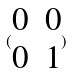Convert formula to latex. <formula><loc_0><loc_0><loc_500><loc_500>( \begin{matrix} 0 & 0 \\ 0 & 1 \end{matrix} )</formula> 